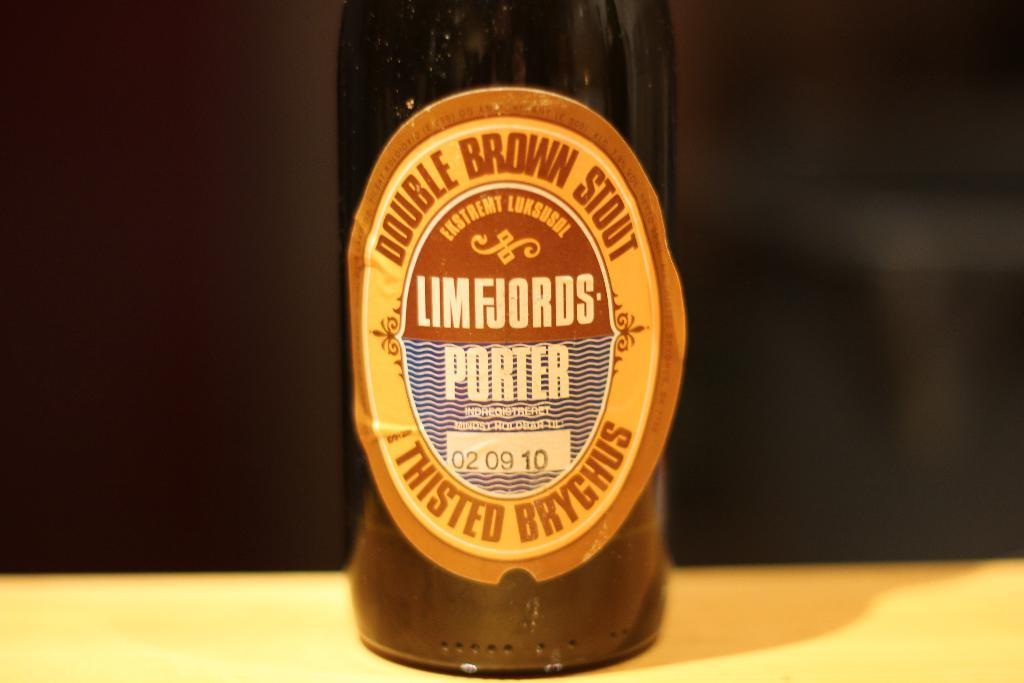<image>
Present a compact description of the photo's key features. A brown bottle of imported double brown stout. 